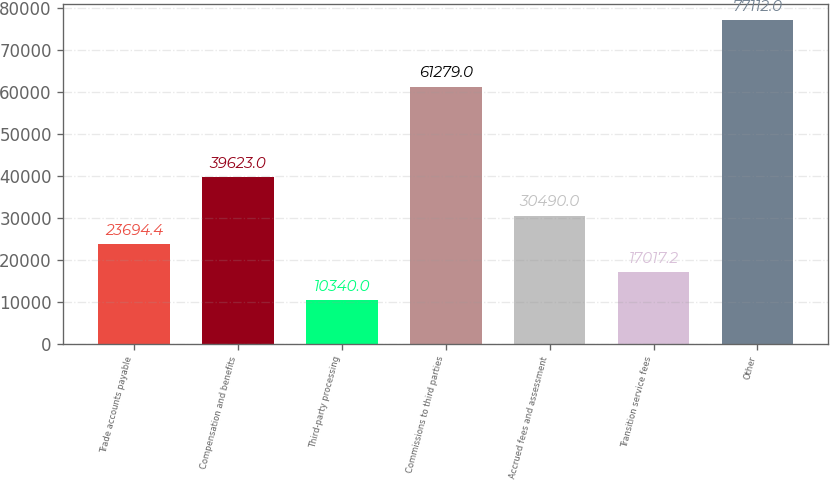Convert chart. <chart><loc_0><loc_0><loc_500><loc_500><bar_chart><fcel>Trade accounts payable<fcel>Compensation and benefits<fcel>Third-party processing<fcel>Commissions to third parties<fcel>Accrued fees and assessment<fcel>Transition service fees<fcel>Other<nl><fcel>23694.4<fcel>39623<fcel>10340<fcel>61279<fcel>30490<fcel>17017.2<fcel>77112<nl></chart> 